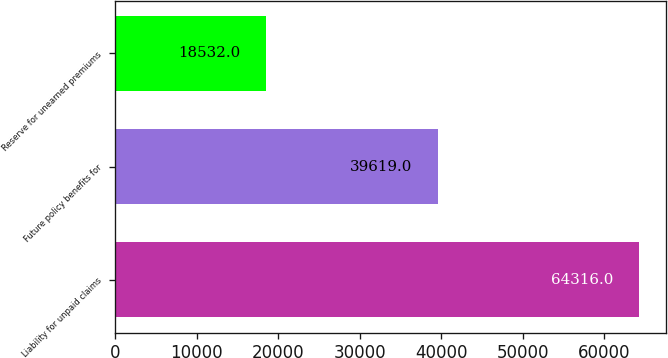Convert chart to OTSL. <chart><loc_0><loc_0><loc_500><loc_500><bar_chart><fcel>Liability for unpaid claims<fcel>Future policy benefits for<fcel>Reserve for unearned premiums<nl><fcel>64316<fcel>39619<fcel>18532<nl></chart> 